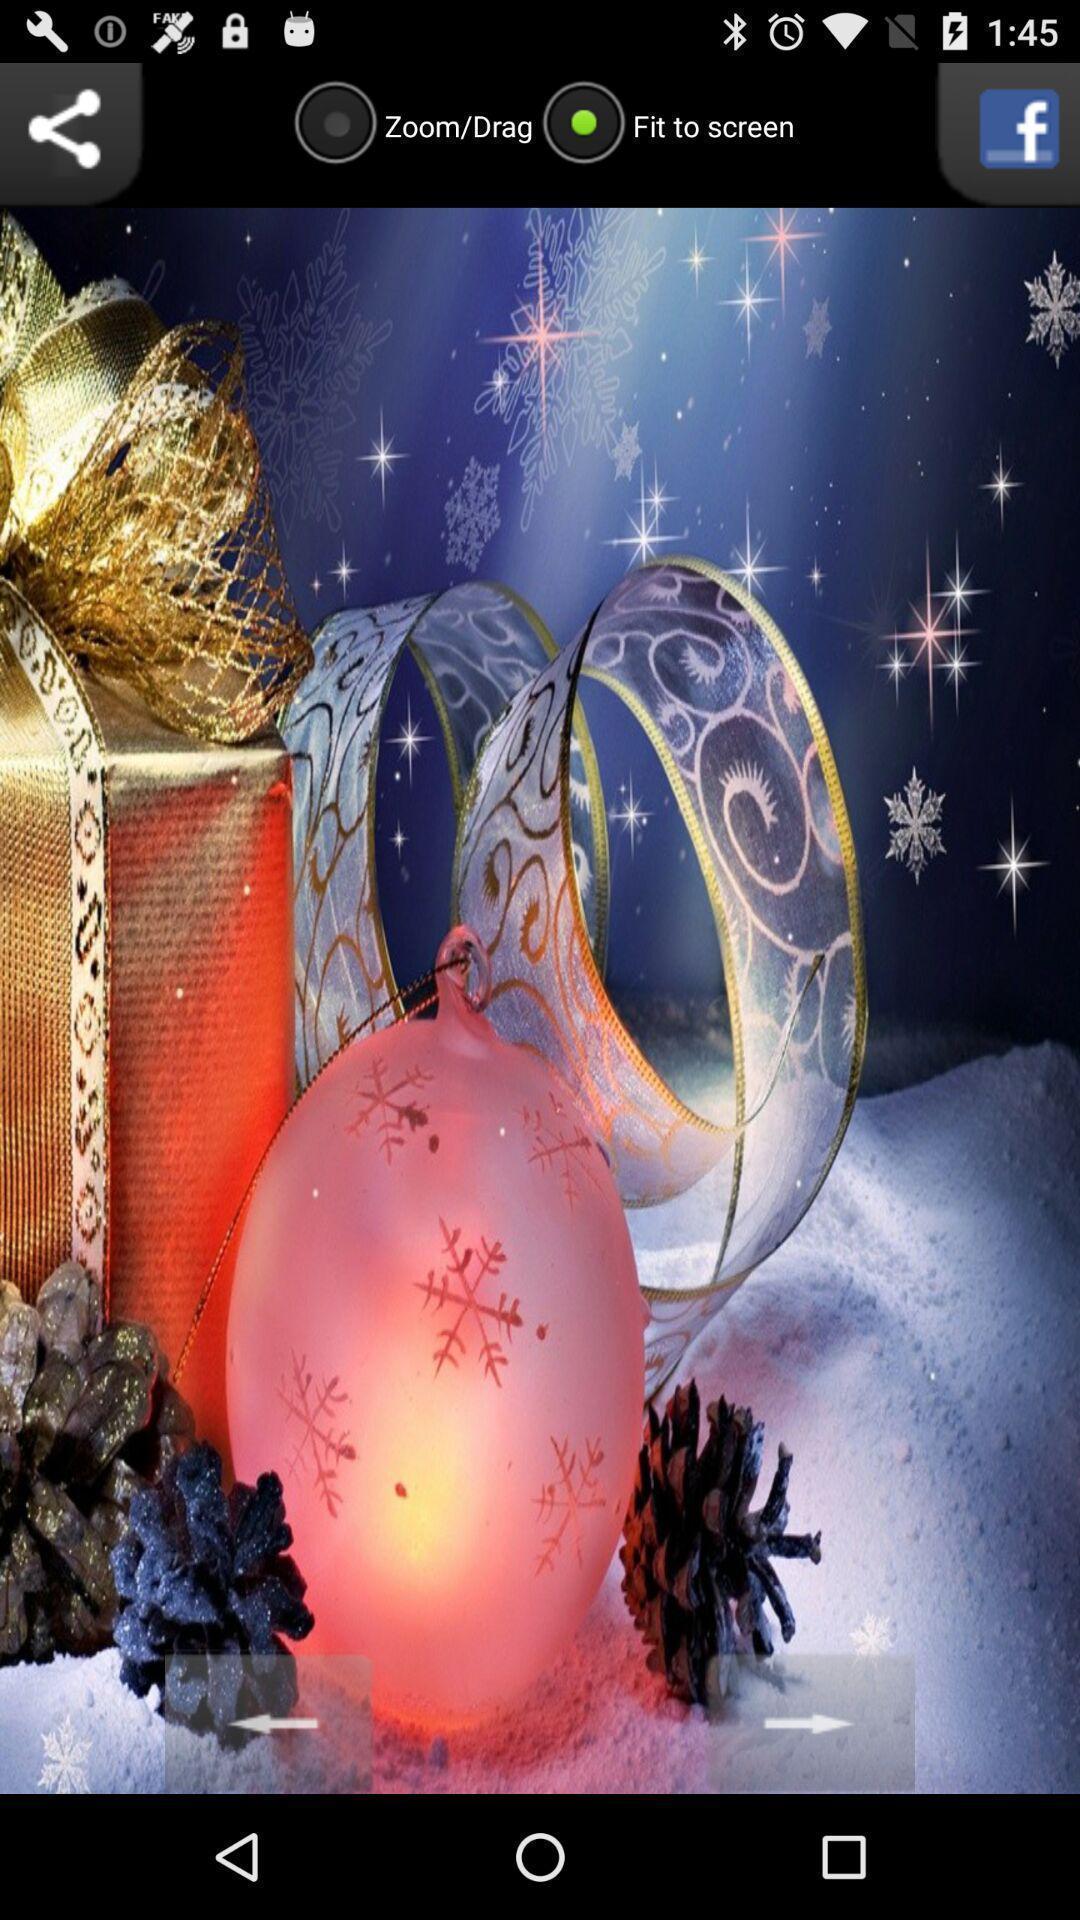Tell me what you see in this picture. Window displaying an image which can be shared. 